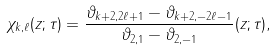Convert formula to latex. <formula><loc_0><loc_0><loc_500><loc_500>\chi _ { k , \ell } ( z ; \tau ) = \frac { \vartheta _ { k + 2 , 2 \ell + 1 } - \vartheta _ { k + 2 , - 2 \ell - 1 } } { \vartheta _ { 2 , 1 } - \vartheta _ { 2 , - 1 } } ( z ; \tau ) ,</formula> 